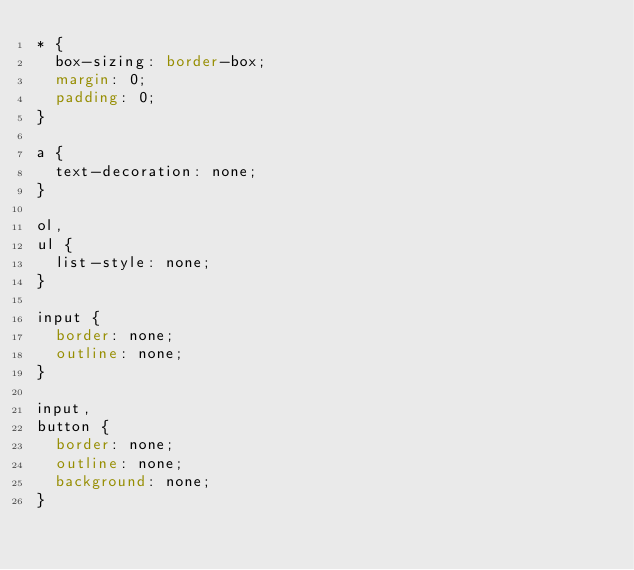<code> <loc_0><loc_0><loc_500><loc_500><_CSS_>* {
	box-sizing: border-box;
	margin: 0;
	padding: 0;
}

a {
	text-decoration: none;
}

ol,
ul {
	list-style: none;
}

input {
	border: none;
	outline: none;
}

input,
button {
	border: none;
	outline: none;
	background: none;
}

</code> 